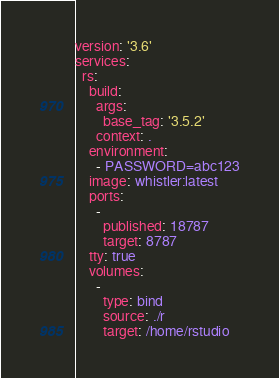<code> <loc_0><loc_0><loc_500><loc_500><_YAML_>version: '3.6'
services:
  rs:
    build:
      args:
        base_tag: '3.5.2'
      context: .
    environment:
      - PASSWORD=abc123
    image: whistler:latest
    ports:
      -
        published: 18787
        target: 8787
    tty: true
    volumes:
      -
        type: bind
        source: ./r
        target: /home/rstudio
</code> 